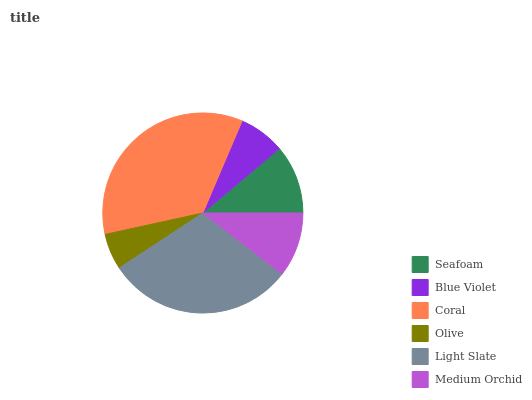Is Olive the minimum?
Answer yes or no. Yes. Is Coral the maximum?
Answer yes or no. Yes. Is Blue Violet the minimum?
Answer yes or no. No. Is Blue Violet the maximum?
Answer yes or no. No. Is Seafoam greater than Blue Violet?
Answer yes or no. Yes. Is Blue Violet less than Seafoam?
Answer yes or no. Yes. Is Blue Violet greater than Seafoam?
Answer yes or no. No. Is Seafoam less than Blue Violet?
Answer yes or no. No. Is Seafoam the high median?
Answer yes or no. Yes. Is Medium Orchid the low median?
Answer yes or no. Yes. Is Blue Violet the high median?
Answer yes or no. No. Is Seafoam the low median?
Answer yes or no. No. 